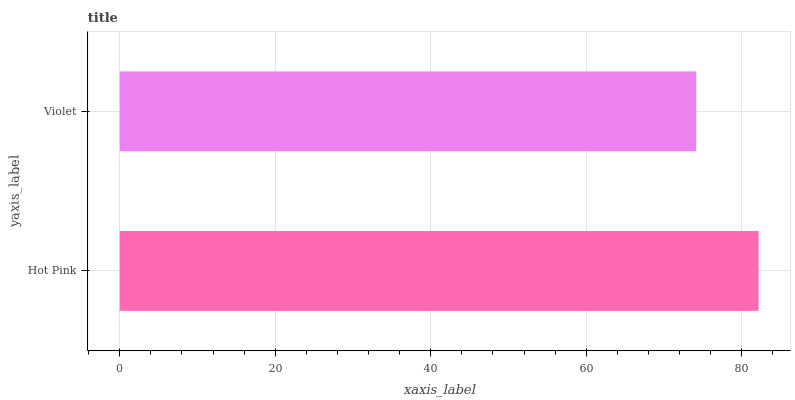Is Violet the minimum?
Answer yes or no. Yes. Is Hot Pink the maximum?
Answer yes or no. Yes. Is Violet the maximum?
Answer yes or no. No. Is Hot Pink greater than Violet?
Answer yes or no. Yes. Is Violet less than Hot Pink?
Answer yes or no. Yes. Is Violet greater than Hot Pink?
Answer yes or no. No. Is Hot Pink less than Violet?
Answer yes or no. No. Is Hot Pink the high median?
Answer yes or no. Yes. Is Violet the low median?
Answer yes or no. Yes. Is Violet the high median?
Answer yes or no. No. Is Hot Pink the low median?
Answer yes or no. No. 